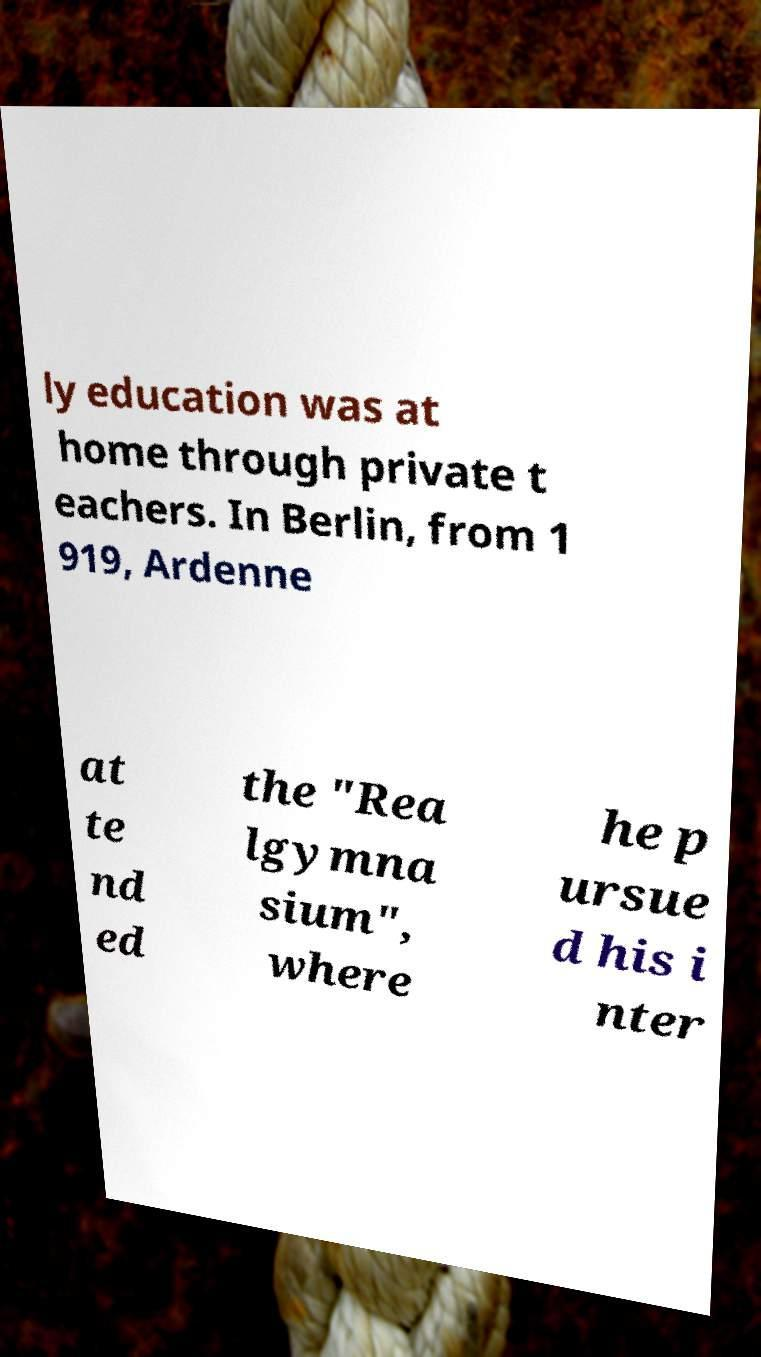Can you read and provide the text displayed in the image?This photo seems to have some interesting text. Can you extract and type it out for me? ly education was at home through private t eachers. In Berlin, from 1 919, Ardenne at te nd ed the "Rea lgymna sium", where he p ursue d his i nter 